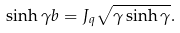Convert formula to latex. <formula><loc_0><loc_0><loc_500><loc_500>\sinh \gamma b = J _ { q } \sqrt { \gamma \sinh \gamma } .</formula> 